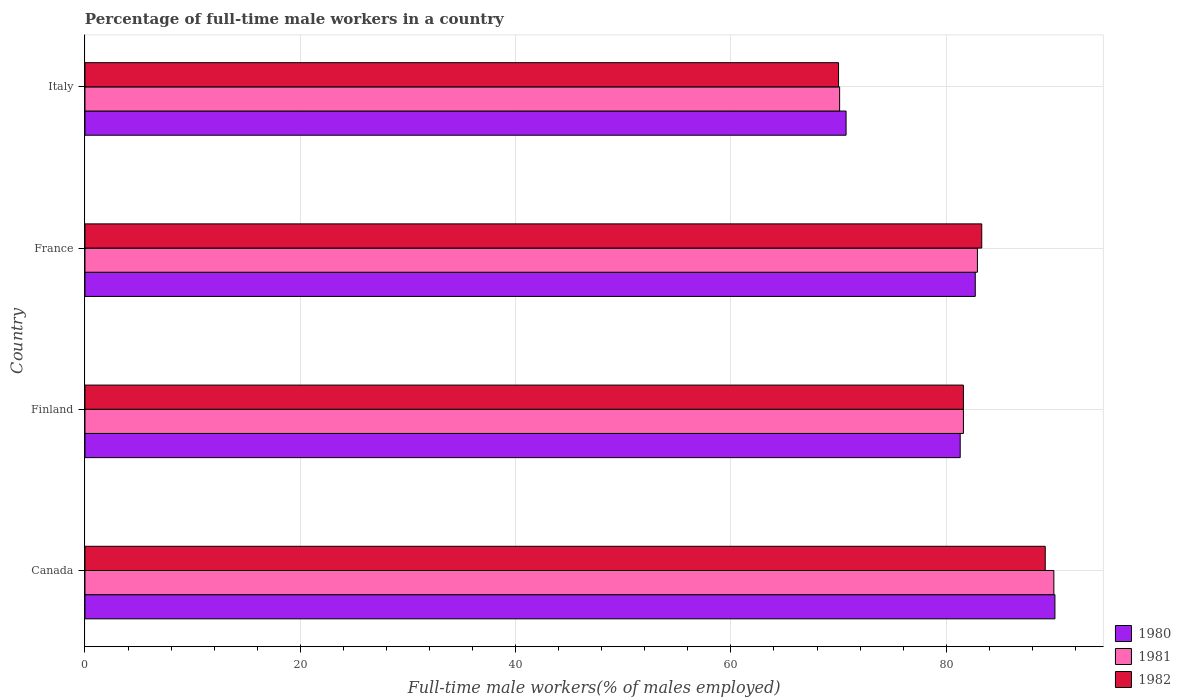Are the number of bars per tick equal to the number of legend labels?
Your answer should be very brief. Yes. Are the number of bars on each tick of the Y-axis equal?
Provide a succinct answer. Yes. How many bars are there on the 4th tick from the top?
Your answer should be very brief. 3. In how many cases, is the number of bars for a given country not equal to the number of legend labels?
Offer a very short reply. 0. What is the percentage of full-time male workers in 1980 in Canada?
Offer a terse response. 90.1. Across all countries, what is the maximum percentage of full-time male workers in 1982?
Provide a succinct answer. 89.2. Across all countries, what is the minimum percentage of full-time male workers in 1980?
Make the answer very short. 70.7. In which country was the percentage of full-time male workers in 1982 minimum?
Offer a terse response. Italy. What is the total percentage of full-time male workers in 1981 in the graph?
Give a very brief answer. 324.6. What is the difference between the percentage of full-time male workers in 1980 in Canada and that in France?
Make the answer very short. 7.4. What is the difference between the percentage of full-time male workers in 1982 in Italy and the percentage of full-time male workers in 1980 in France?
Your answer should be very brief. -12.7. What is the average percentage of full-time male workers in 1981 per country?
Offer a very short reply. 81.15. What is the difference between the percentage of full-time male workers in 1980 and percentage of full-time male workers in 1981 in France?
Provide a succinct answer. -0.2. What is the ratio of the percentage of full-time male workers in 1980 in France to that in Italy?
Give a very brief answer. 1.17. Is the percentage of full-time male workers in 1980 in Canada less than that in France?
Your response must be concise. No. Is the difference between the percentage of full-time male workers in 1980 in Canada and Finland greater than the difference between the percentage of full-time male workers in 1981 in Canada and Finland?
Provide a short and direct response. Yes. What is the difference between the highest and the second highest percentage of full-time male workers in 1981?
Keep it short and to the point. 7.1. What is the difference between the highest and the lowest percentage of full-time male workers in 1981?
Provide a succinct answer. 19.9. Is the sum of the percentage of full-time male workers in 1982 in Finland and Italy greater than the maximum percentage of full-time male workers in 1980 across all countries?
Offer a terse response. Yes. What does the 3rd bar from the top in Canada represents?
Give a very brief answer. 1980. What does the 1st bar from the bottom in Canada represents?
Offer a very short reply. 1980. Is it the case that in every country, the sum of the percentage of full-time male workers in 1981 and percentage of full-time male workers in 1980 is greater than the percentage of full-time male workers in 1982?
Ensure brevity in your answer.  Yes. How many countries are there in the graph?
Offer a terse response. 4. What is the difference between two consecutive major ticks on the X-axis?
Your response must be concise. 20. Does the graph contain grids?
Your answer should be compact. Yes. Where does the legend appear in the graph?
Provide a short and direct response. Bottom right. What is the title of the graph?
Make the answer very short. Percentage of full-time male workers in a country. What is the label or title of the X-axis?
Provide a succinct answer. Full-time male workers(% of males employed). What is the Full-time male workers(% of males employed) of 1980 in Canada?
Provide a succinct answer. 90.1. What is the Full-time male workers(% of males employed) in 1982 in Canada?
Provide a short and direct response. 89.2. What is the Full-time male workers(% of males employed) in 1980 in Finland?
Keep it short and to the point. 81.3. What is the Full-time male workers(% of males employed) in 1981 in Finland?
Provide a short and direct response. 81.6. What is the Full-time male workers(% of males employed) in 1982 in Finland?
Your response must be concise. 81.6. What is the Full-time male workers(% of males employed) in 1980 in France?
Your answer should be compact. 82.7. What is the Full-time male workers(% of males employed) of 1981 in France?
Keep it short and to the point. 82.9. What is the Full-time male workers(% of males employed) in 1982 in France?
Your response must be concise. 83.3. What is the Full-time male workers(% of males employed) in 1980 in Italy?
Ensure brevity in your answer.  70.7. What is the Full-time male workers(% of males employed) in 1981 in Italy?
Provide a short and direct response. 70.1. Across all countries, what is the maximum Full-time male workers(% of males employed) of 1980?
Provide a succinct answer. 90.1. Across all countries, what is the maximum Full-time male workers(% of males employed) of 1981?
Your answer should be compact. 90. Across all countries, what is the maximum Full-time male workers(% of males employed) of 1982?
Your answer should be compact. 89.2. Across all countries, what is the minimum Full-time male workers(% of males employed) of 1980?
Your answer should be very brief. 70.7. Across all countries, what is the minimum Full-time male workers(% of males employed) in 1981?
Keep it short and to the point. 70.1. Across all countries, what is the minimum Full-time male workers(% of males employed) in 1982?
Your answer should be very brief. 70. What is the total Full-time male workers(% of males employed) of 1980 in the graph?
Offer a terse response. 324.8. What is the total Full-time male workers(% of males employed) of 1981 in the graph?
Make the answer very short. 324.6. What is the total Full-time male workers(% of males employed) in 1982 in the graph?
Offer a very short reply. 324.1. What is the difference between the Full-time male workers(% of males employed) in 1982 in Canada and that in Finland?
Your answer should be compact. 7.6. What is the difference between the Full-time male workers(% of males employed) in 1981 in Canada and that in France?
Keep it short and to the point. 7.1. What is the difference between the Full-time male workers(% of males employed) of 1981 in Canada and that in Italy?
Make the answer very short. 19.9. What is the difference between the Full-time male workers(% of males employed) of 1982 in Finland and that in France?
Offer a terse response. -1.7. What is the difference between the Full-time male workers(% of males employed) in 1980 in Finland and that in Italy?
Offer a terse response. 10.6. What is the difference between the Full-time male workers(% of males employed) of 1980 in France and that in Italy?
Your answer should be very brief. 12. What is the difference between the Full-time male workers(% of males employed) in 1981 in France and that in Italy?
Provide a succinct answer. 12.8. What is the difference between the Full-time male workers(% of males employed) of 1980 in Canada and the Full-time male workers(% of males employed) of 1982 in Finland?
Keep it short and to the point. 8.5. What is the difference between the Full-time male workers(% of males employed) in 1980 in Canada and the Full-time male workers(% of males employed) in 1981 in France?
Offer a very short reply. 7.2. What is the difference between the Full-time male workers(% of males employed) in 1980 in Canada and the Full-time male workers(% of males employed) in 1982 in France?
Give a very brief answer. 6.8. What is the difference between the Full-time male workers(% of males employed) of 1981 in Canada and the Full-time male workers(% of males employed) of 1982 in France?
Ensure brevity in your answer.  6.7. What is the difference between the Full-time male workers(% of males employed) of 1980 in Canada and the Full-time male workers(% of males employed) of 1982 in Italy?
Give a very brief answer. 20.1. What is the difference between the Full-time male workers(% of males employed) of 1981 in Canada and the Full-time male workers(% of males employed) of 1982 in Italy?
Provide a succinct answer. 20. What is the difference between the Full-time male workers(% of males employed) of 1981 in Finland and the Full-time male workers(% of males employed) of 1982 in France?
Your answer should be compact. -1.7. What is the difference between the Full-time male workers(% of males employed) in 1980 in Finland and the Full-time male workers(% of males employed) in 1981 in Italy?
Keep it short and to the point. 11.2. What is the difference between the Full-time male workers(% of males employed) of 1981 in Finland and the Full-time male workers(% of males employed) of 1982 in Italy?
Keep it short and to the point. 11.6. What is the average Full-time male workers(% of males employed) in 1980 per country?
Ensure brevity in your answer.  81.2. What is the average Full-time male workers(% of males employed) of 1981 per country?
Offer a very short reply. 81.15. What is the average Full-time male workers(% of males employed) in 1982 per country?
Provide a short and direct response. 81.03. What is the difference between the Full-time male workers(% of males employed) of 1980 and Full-time male workers(% of males employed) of 1982 in Canada?
Your answer should be very brief. 0.9. What is the difference between the Full-time male workers(% of males employed) of 1980 and Full-time male workers(% of males employed) of 1981 in France?
Keep it short and to the point. -0.2. What is the difference between the Full-time male workers(% of males employed) of 1980 and Full-time male workers(% of males employed) of 1981 in Italy?
Your answer should be very brief. 0.6. What is the difference between the Full-time male workers(% of males employed) in 1981 and Full-time male workers(% of males employed) in 1982 in Italy?
Ensure brevity in your answer.  0.1. What is the ratio of the Full-time male workers(% of males employed) in 1980 in Canada to that in Finland?
Make the answer very short. 1.11. What is the ratio of the Full-time male workers(% of males employed) of 1981 in Canada to that in Finland?
Make the answer very short. 1.1. What is the ratio of the Full-time male workers(% of males employed) in 1982 in Canada to that in Finland?
Make the answer very short. 1.09. What is the ratio of the Full-time male workers(% of males employed) of 1980 in Canada to that in France?
Your response must be concise. 1.09. What is the ratio of the Full-time male workers(% of males employed) of 1981 in Canada to that in France?
Offer a very short reply. 1.09. What is the ratio of the Full-time male workers(% of males employed) in 1982 in Canada to that in France?
Provide a succinct answer. 1.07. What is the ratio of the Full-time male workers(% of males employed) in 1980 in Canada to that in Italy?
Your response must be concise. 1.27. What is the ratio of the Full-time male workers(% of males employed) in 1981 in Canada to that in Italy?
Make the answer very short. 1.28. What is the ratio of the Full-time male workers(% of males employed) of 1982 in Canada to that in Italy?
Make the answer very short. 1.27. What is the ratio of the Full-time male workers(% of males employed) of 1980 in Finland to that in France?
Give a very brief answer. 0.98. What is the ratio of the Full-time male workers(% of males employed) of 1981 in Finland to that in France?
Your answer should be compact. 0.98. What is the ratio of the Full-time male workers(% of males employed) in 1982 in Finland to that in France?
Offer a terse response. 0.98. What is the ratio of the Full-time male workers(% of males employed) of 1980 in Finland to that in Italy?
Your response must be concise. 1.15. What is the ratio of the Full-time male workers(% of males employed) of 1981 in Finland to that in Italy?
Give a very brief answer. 1.16. What is the ratio of the Full-time male workers(% of males employed) in 1982 in Finland to that in Italy?
Ensure brevity in your answer.  1.17. What is the ratio of the Full-time male workers(% of males employed) of 1980 in France to that in Italy?
Keep it short and to the point. 1.17. What is the ratio of the Full-time male workers(% of males employed) of 1981 in France to that in Italy?
Offer a very short reply. 1.18. What is the ratio of the Full-time male workers(% of males employed) of 1982 in France to that in Italy?
Your answer should be very brief. 1.19. What is the difference between the highest and the second highest Full-time male workers(% of males employed) in 1982?
Provide a short and direct response. 5.9. What is the difference between the highest and the lowest Full-time male workers(% of males employed) of 1980?
Provide a succinct answer. 19.4. What is the difference between the highest and the lowest Full-time male workers(% of males employed) in 1981?
Give a very brief answer. 19.9. What is the difference between the highest and the lowest Full-time male workers(% of males employed) in 1982?
Your answer should be compact. 19.2. 